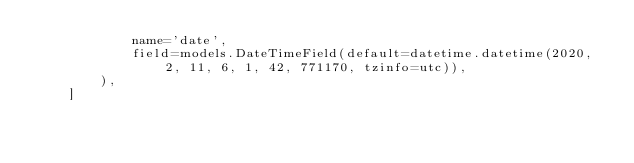Convert code to text. <code><loc_0><loc_0><loc_500><loc_500><_Python_>            name='date',
            field=models.DateTimeField(default=datetime.datetime(2020, 2, 11, 6, 1, 42, 771170, tzinfo=utc)),
        ),
    ]
</code> 